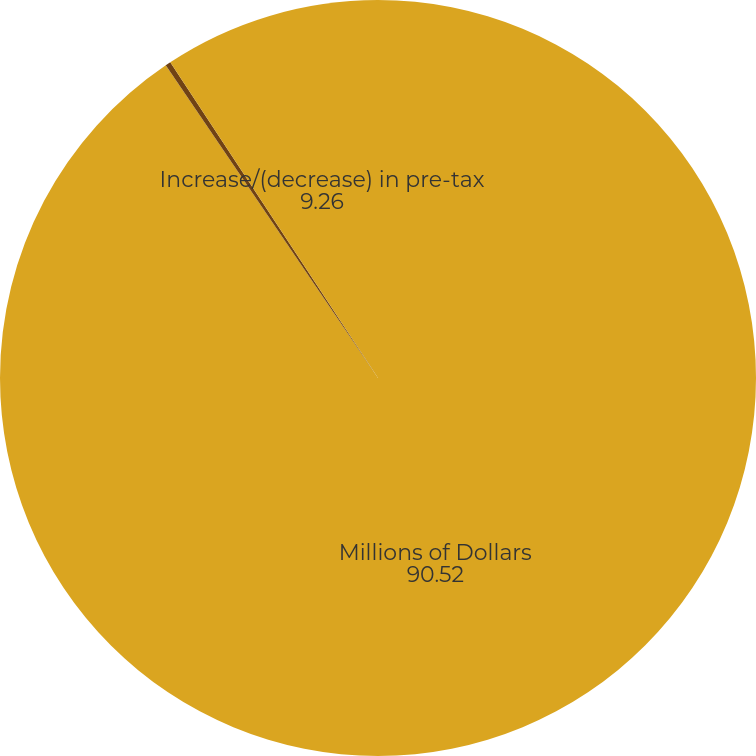Convert chart. <chart><loc_0><loc_0><loc_500><loc_500><pie_chart><fcel>Millions of Dollars<fcel>(Increase)/decrease in<fcel>Increase/(decrease) in pre-tax<nl><fcel>90.52%<fcel>0.23%<fcel>9.26%<nl></chart> 